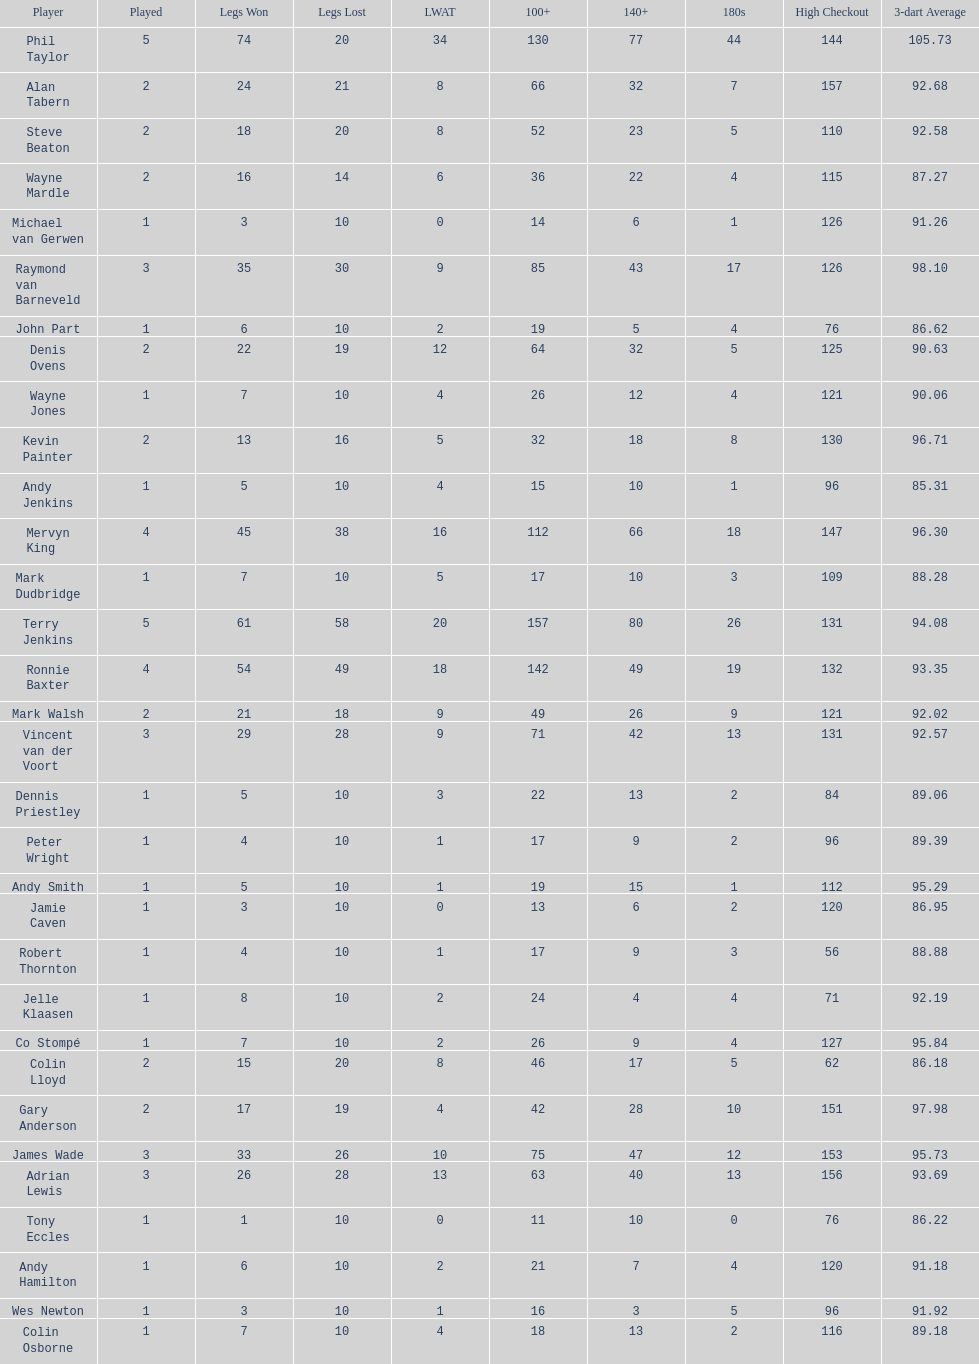What were the total number of legs won by ronnie baxter? 54. 